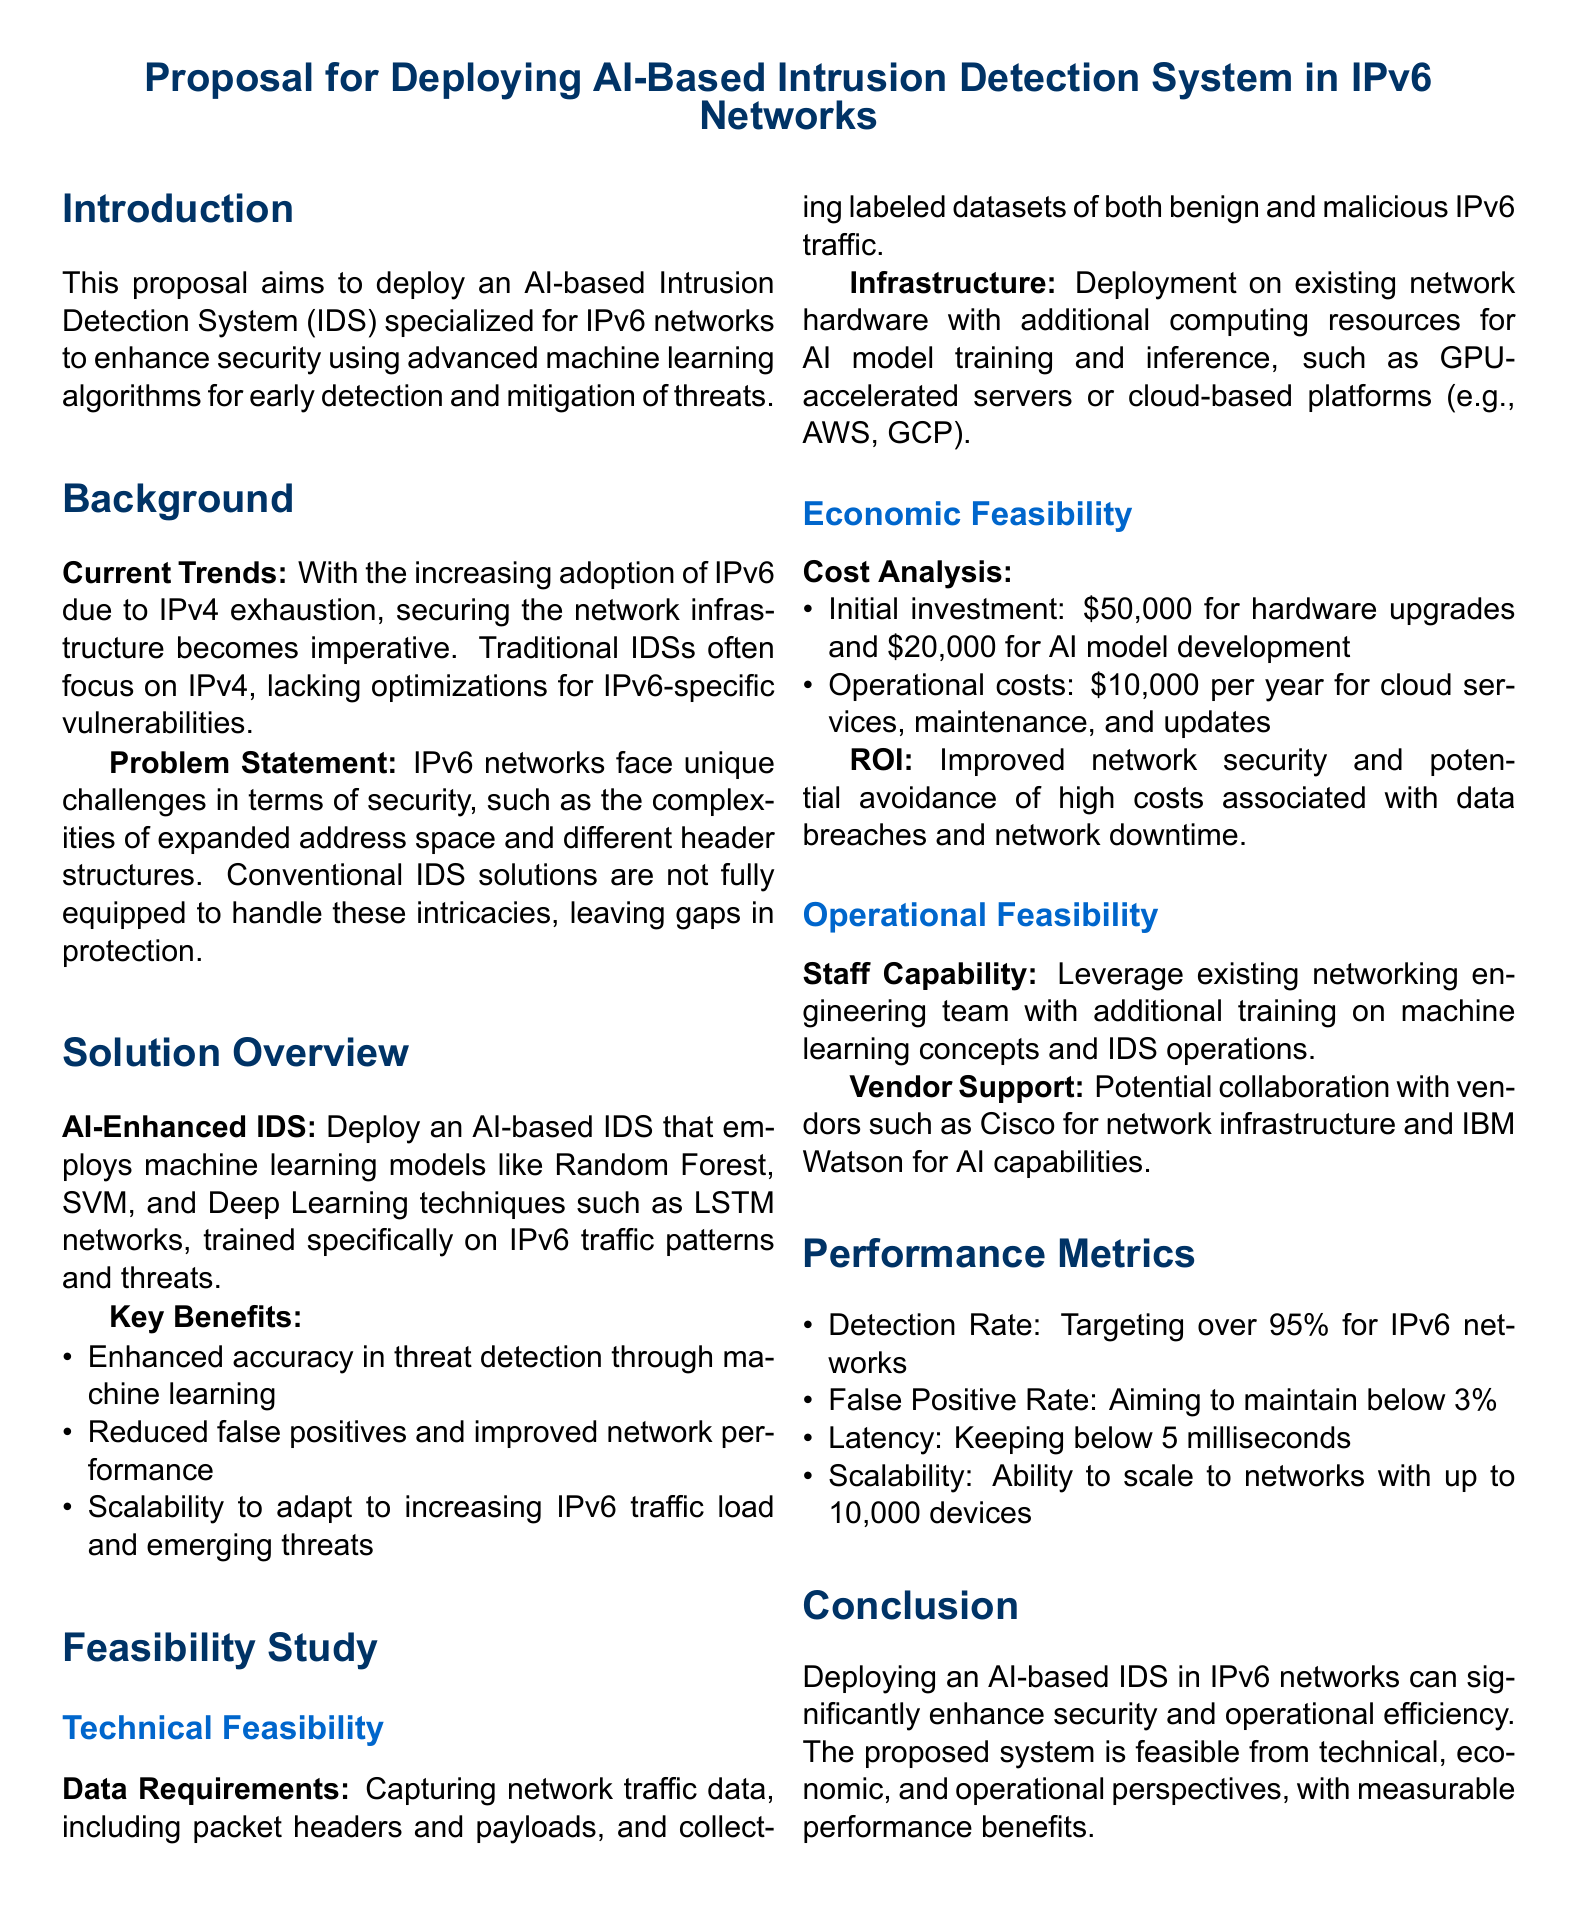What is the main focus of the proposal? The proposal focuses on deploying an AI-based Intrusion Detection System specialized for IPv6 networks.
Answer: AI-based Intrusion Detection System What is the initial investment amount for hardware upgrades? The document specifies that the initial investment for hardware upgrades is $50,000.
Answer: $50,000 What is the target detection rate for the IDS? The proposal aims for a detection rate of over 95% for IPv6 networks.
Answer: 95% Who are the potential vendors mentioned for collaboration? The proposal mentions Cisco and IBM Watson as potential vendors for collaboration.
Answer: Cisco, IBM Watson What is the maximum acceptable false positive rate? The document states that the goal is to maintain a false positive rate below 3%.
Answer: 3% What is the estimated annual operational cost for cloud services? The annual operational cost for cloud services, maintenance, and updates is estimated to be $10,000.
Answer: $10,000 What type of machine learning models are proposed for the IDS? The proposal includes Random Forest, SVM, and Deep Learning techniques such as LSTM networks.
Answer: Random Forest, SVM, LSTM What is the scalability target for the network device capacity? The proposed system should be able to scale to networks with up to 10,000 devices.
Answer: 10,000 devices 